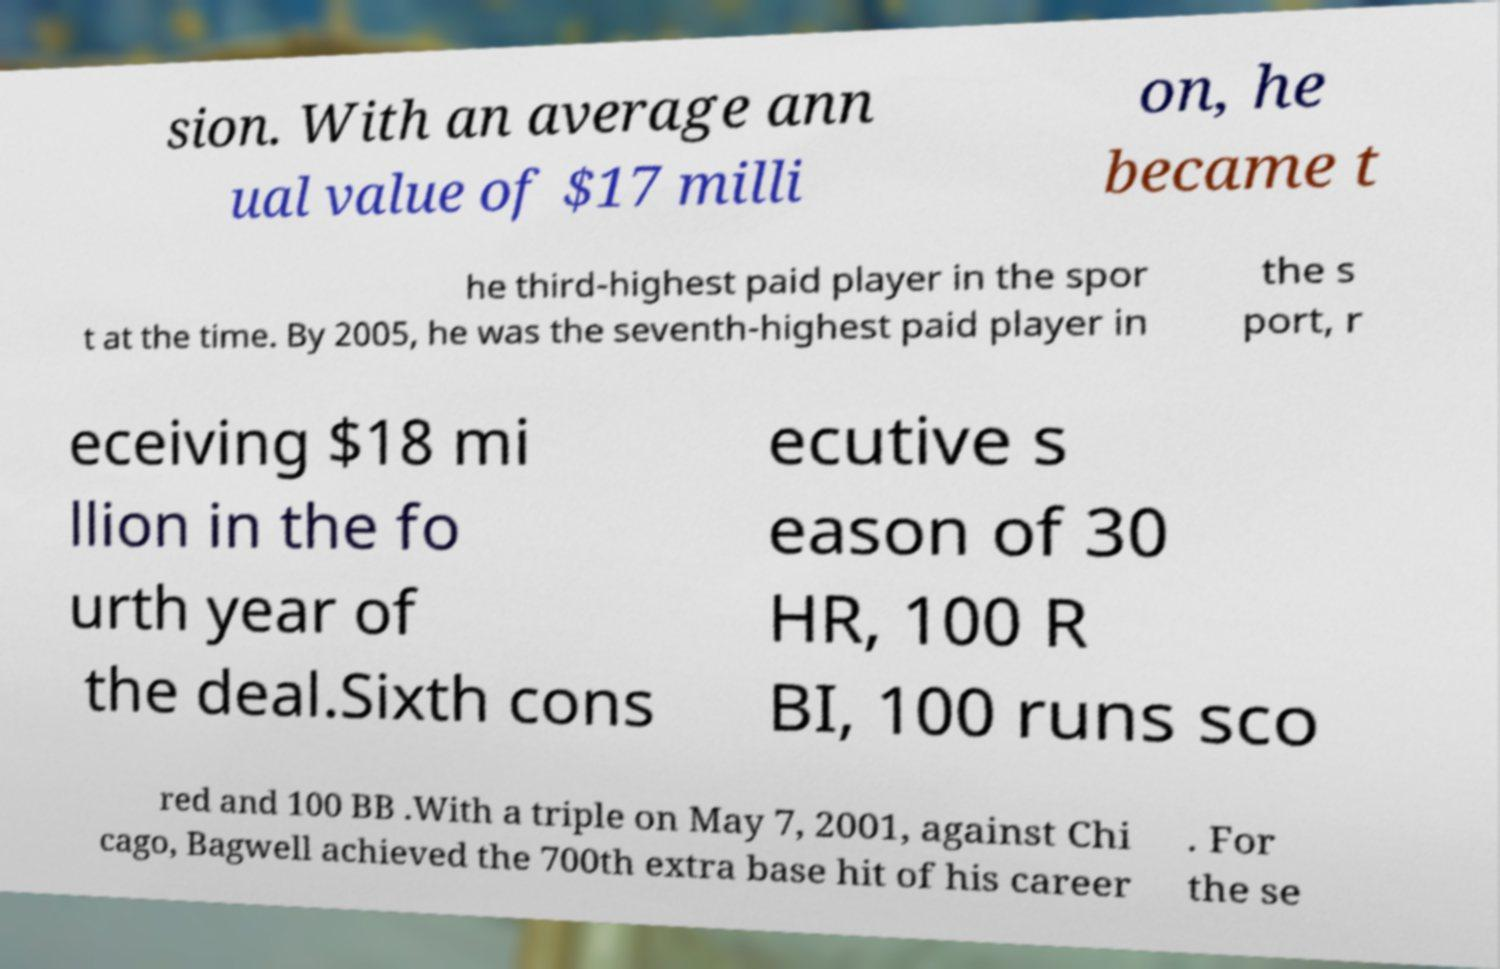There's text embedded in this image that I need extracted. Can you transcribe it verbatim? sion. With an average ann ual value of $17 milli on, he became t he third-highest paid player in the spor t at the time. By 2005, he was the seventh-highest paid player in the s port, r eceiving $18 mi llion in the fo urth year of the deal.Sixth cons ecutive s eason of 30 HR, 100 R BI, 100 runs sco red and 100 BB .With a triple on May 7, 2001, against Chi cago, Bagwell achieved the 700th extra base hit of his career . For the se 